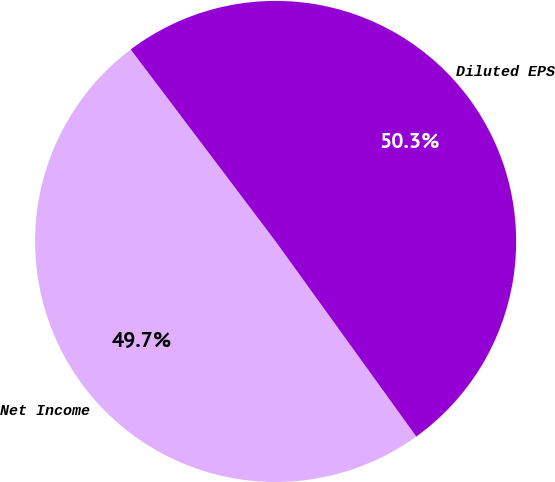<chart> <loc_0><loc_0><loc_500><loc_500><pie_chart><fcel>Net Income<fcel>Diluted EPS<nl><fcel>49.65%<fcel>50.35%<nl></chart> 